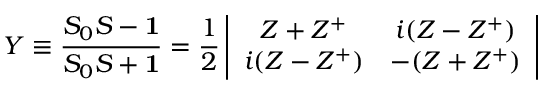Convert formula to latex. <formula><loc_0><loc_0><loc_500><loc_500>Y \equiv \frac { S _ { 0 } S - { 1 } } { S _ { 0 } S + { 1 } } = \frac { 1 } { 2 } \left | \begin{array} { c c } { { Z + Z ^ { + } } } & { { i ( Z - Z ^ { + } ) } } \\ { { i ( Z - Z ^ { + } ) } } & { { - ( Z + Z ^ { + } ) } } \end{array} \right |</formula> 